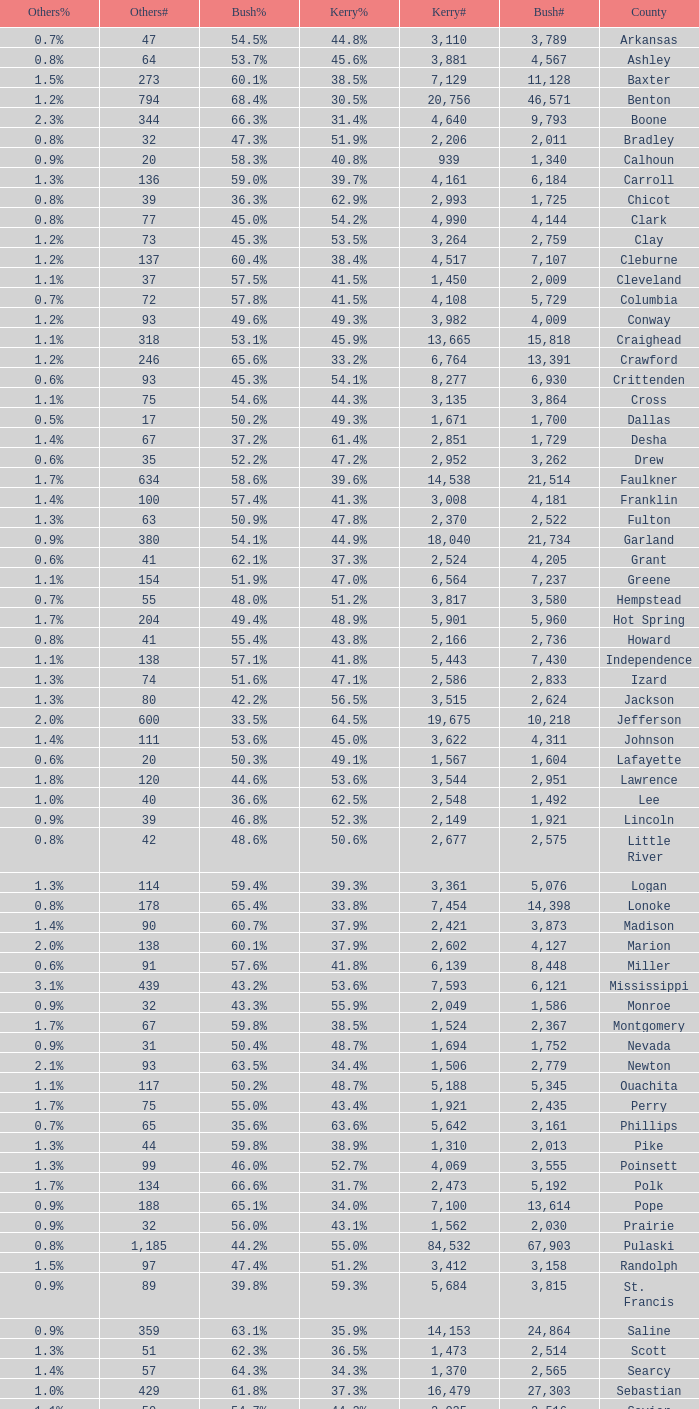Give me the full table as a dictionary. {'header': ['Others%', 'Others#', 'Bush%', 'Kerry%', 'Kerry#', 'Bush#', 'County'], 'rows': [['0.7%', '47', '54.5%', '44.8%', '3,110', '3,789', 'Arkansas'], ['0.8%', '64', '53.7%', '45.6%', '3,881', '4,567', 'Ashley'], ['1.5%', '273', '60.1%', '38.5%', '7,129', '11,128', 'Baxter'], ['1.2%', '794', '68.4%', '30.5%', '20,756', '46,571', 'Benton'], ['2.3%', '344', '66.3%', '31.4%', '4,640', '9,793', 'Boone'], ['0.8%', '32', '47.3%', '51.9%', '2,206', '2,011', 'Bradley'], ['0.9%', '20', '58.3%', '40.8%', '939', '1,340', 'Calhoun'], ['1.3%', '136', '59.0%', '39.7%', '4,161', '6,184', 'Carroll'], ['0.8%', '39', '36.3%', '62.9%', '2,993', '1,725', 'Chicot'], ['0.8%', '77', '45.0%', '54.2%', '4,990', '4,144', 'Clark'], ['1.2%', '73', '45.3%', '53.5%', '3,264', '2,759', 'Clay'], ['1.2%', '137', '60.4%', '38.4%', '4,517', '7,107', 'Cleburne'], ['1.1%', '37', '57.5%', '41.5%', '1,450', '2,009', 'Cleveland'], ['0.7%', '72', '57.8%', '41.5%', '4,108', '5,729', 'Columbia'], ['1.2%', '93', '49.6%', '49.3%', '3,982', '4,009', 'Conway'], ['1.1%', '318', '53.1%', '45.9%', '13,665', '15,818', 'Craighead'], ['1.2%', '246', '65.6%', '33.2%', '6,764', '13,391', 'Crawford'], ['0.6%', '93', '45.3%', '54.1%', '8,277', '6,930', 'Crittenden'], ['1.1%', '75', '54.6%', '44.3%', '3,135', '3,864', 'Cross'], ['0.5%', '17', '50.2%', '49.3%', '1,671', '1,700', 'Dallas'], ['1.4%', '67', '37.2%', '61.4%', '2,851', '1,729', 'Desha'], ['0.6%', '35', '52.2%', '47.2%', '2,952', '3,262', 'Drew'], ['1.7%', '634', '58.6%', '39.6%', '14,538', '21,514', 'Faulkner'], ['1.4%', '100', '57.4%', '41.3%', '3,008', '4,181', 'Franklin'], ['1.3%', '63', '50.9%', '47.8%', '2,370', '2,522', 'Fulton'], ['0.9%', '380', '54.1%', '44.9%', '18,040', '21,734', 'Garland'], ['0.6%', '41', '62.1%', '37.3%', '2,524', '4,205', 'Grant'], ['1.1%', '154', '51.9%', '47.0%', '6,564', '7,237', 'Greene'], ['0.7%', '55', '48.0%', '51.2%', '3,817', '3,580', 'Hempstead'], ['1.7%', '204', '49.4%', '48.9%', '5,901', '5,960', 'Hot Spring'], ['0.8%', '41', '55.4%', '43.8%', '2,166', '2,736', 'Howard'], ['1.1%', '138', '57.1%', '41.8%', '5,443', '7,430', 'Independence'], ['1.3%', '74', '51.6%', '47.1%', '2,586', '2,833', 'Izard'], ['1.3%', '80', '42.2%', '56.5%', '3,515', '2,624', 'Jackson'], ['2.0%', '600', '33.5%', '64.5%', '19,675', '10,218', 'Jefferson'], ['1.4%', '111', '53.6%', '45.0%', '3,622', '4,311', 'Johnson'], ['0.6%', '20', '50.3%', '49.1%', '1,567', '1,604', 'Lafayette'], ['1.8%', '120', '44.6%', '53.6%', '3,544', '2,951', 'Lawrence'], ['1.0%', '40', '36.6%', '62.5%', '2,548', '1,492', 'Lee'], ['0.9%', '39', '46.8%', '52.3%', '2,149', '1,921', 'Lincoln'], ['0.8%', '42', '48.6%', '50.6%', '2,677', '2,575', 'Little River'], ['1.3%', '114', '59.4%', '39.3%', '3,361', '5,076', 'Logan'], ['0.8%', '178', '65.4%', '33.8%', '7,454', '14,398', 'Lonoke'], ['1.4%', '90', '60.7%', '37.9%', '2,421', '3,873', 'Madison'], ['2.0%', '138', '60.1%', '37.9%', '2,602', '4,127', 'Marion'], ['0.6%', '91', '57.6%', '41.8%', '6,139', '8,448', 'Miller'], ['3.1%', '439', '43.2%', '53.6%', '7,593', '6,121', 'Mississippi'], ['0.9%', '32', '43.3%', '55.9%', '2,049', '1,586', 'Monroe'], ['1.7%', '67', '59.8%', '38.5%', '1,524', '2,367', 'Montgomery'], ['0.9%', '31', '50.4%', '48.7%', '1,694', '1,752', 'Nevada'], ['2.1%', '93', '63.5%', '34.4%', '1,506', '2,779', 'Newton'], ['1.1%', '117', '50.2%', '48.7%', '5,188', '5,345', 'Ouachita'], ['1.7%', '75', '55.0%', '43.4%', '1,921', '2,435', 'Perry'], ['0.7%', '65', '35.6%', '63.6%', '5,642', '3,161', 'Phillips'], ['1.3%', '44', '59.8%', '38.9%', '1,310', '2,013', 'Pike'], ['1.3%', '99', '46.0%', '52.7%', '4,069', '3,555', 'Poinsett'], ['1.7%', '134', '66.6%', '31.7%', '2,473', '5,192', 'Polk'], ['0.9%', '188', '65.1%', '34.0%', '7,100', '13,614', 'Pope'], ['0.9%', '32', '56.0%', '43.1%', '1,562', '2,030', 'Prairie'], ['0.8%', '1,185', '44.2%', '55.0%', '84,532', '67,903', 'Pulaski'], ['1.5%', '97', '47.4%', '51.2%', '3,412', '3,158', 'Randolph'], ['0.9%', '89', '39.8%', '59.3%', '5,684', '3,815', 'St. Francis'], ['0.9%', '359', '63.1%', '35.9%', '14,153', '24,864', 'Saline'], ['1.3%', '51', '62.3%', '36.5%', '1,473', '2,514', 'Scott'], ['1.4%', '57', '64.3%', '34.3%', '1,370', '2,565', 'Searcy'], ['1.0%', '429', '61.8%', '37.3%', '16,479', '27,303', 'Sebastian'], ['1.1%', '50', '54.7%', '44.2%', '2,035', '2,516', 'Sevier'], ['1.4%', '108', '54.8%', '43.7%', '3,265', '4,097', 'Sharp'], ['1.9%', '106', '57.5%', '40.6%', '2,255', '3,188', 'Stone'], ['1.5%', '259', '58.9%', '39.7%', '7,071', '10,502', 'Union'], ['1.0%', '76', '54.1%', '44.9%', '3,310', '3,988', 'Van Buren'], ['1.2%', '780', '55.7%', '43.1%', '27,597', '35,726', 'Washington'], ['1.1%', '295', '64.3%', '34.5%', '9,129', '17,001', 'White'], ['1.1%', '33', '33.7%', '65.2%', '1,972', '1,021', 'Woodruff'], ['1.0%', '68', '55.2%', '43.7%', '2,913', '3,678', 'Yell']]} What is the lowest Kerry#, when Others# is "106", and when Bush# is less than 3,188? None. 